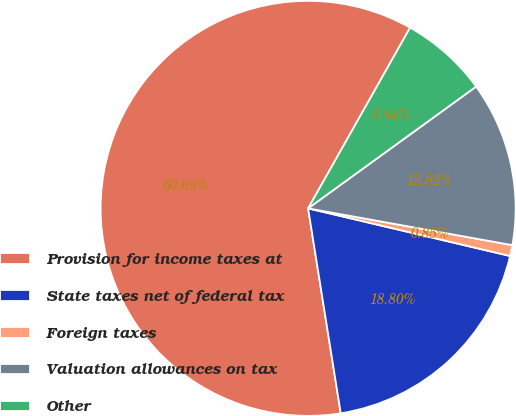Convert chart. <chart><loc_0><loc_0><loc_500><loc_500><pie_chart><fcel>Provision for income taxes at<fcel>State taxes net of federal tax<fcel>Foreign taxes<fcel>Valuation allowances on tax<fcel>Other<nl><fcel>60.69%<fcel>18.8%<fcel>0.85%<fcel>12.82%<fcel>6.84%<nl></chart> 